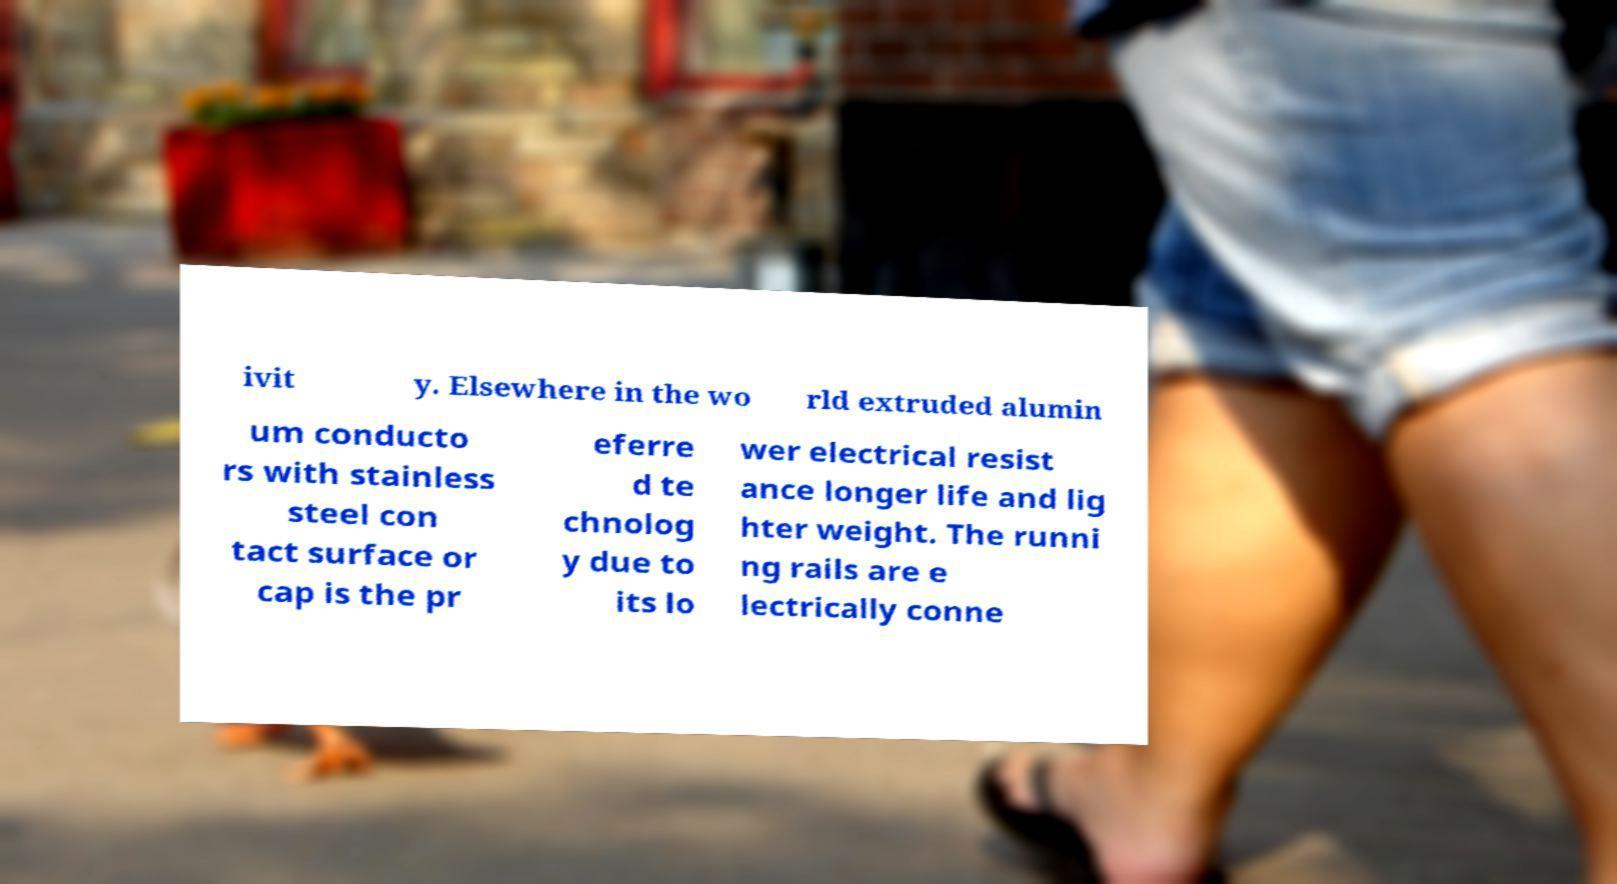For documentation purposes, I need the text within this image transcribed. Could you provide that? ivit y. Elsewhere in the wo rld extruded alumin um conducto rs with stainless steel con tact surface or cap is the pr eferre d te chnolog y due to its lo wer electrical resist ance longer life and lig hter weight. The runni ng rails are e lectrically conne 